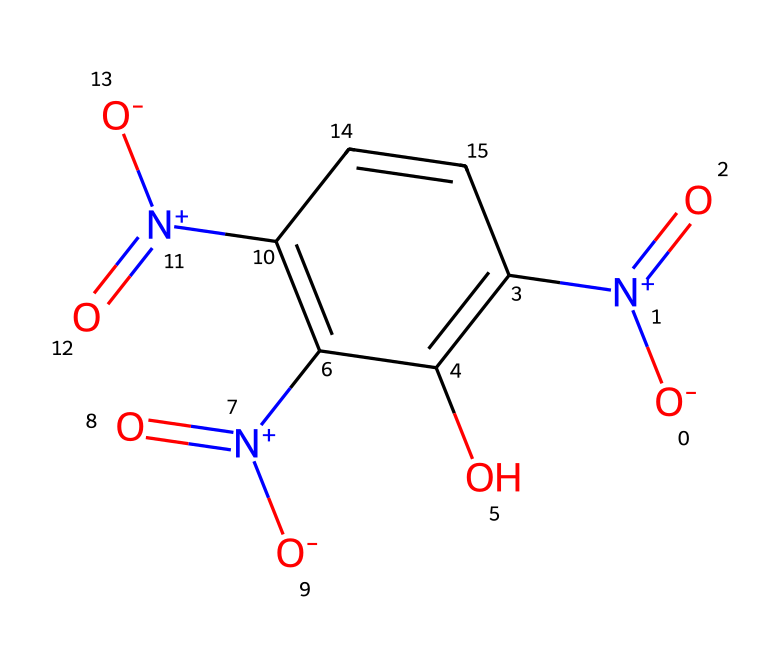What is the molecular formula of picric acid? By analyzing the structure, we identify the types and number of atoms present. Picric acid consists of carbon (C), hydrogen (H), nitrogen (N), and oxygen (O) atoms. Counting each, we have 6 carbon atoms, 3 hydrogen atoms, 3 nitrogen atoms, and 6 oxygen atoms, leading to the molecular formula C6H3N3O6.
Answer: C6H3N3O6 How many nitro groups are present in the structure? Looking at the structure, we see that there are three distinct -NO2 groups attached to the aromatic ring. Each nitro group can be identified by the presence of nitrogen bonded to two oxygen atoms. Counting these, we get three nitro groups in total.
Answer: 3 What type of compound is picric acid classified as? Picric acid has multiple nitro functional groups attached to an aromatic ring, which characterizes it as an aromatic explosive compound. The presence of these nitro groups classifies it as a nitro compound.
Answer: nitro compound Which functional group is responsible for the acidic property in picric acid? Upon examining the structure, we find a hydroxyl (-OH) group attached to the aromatic ring. This hydroxyl group is what gives picric acid its acidic properties, as it can donate a proton (H+) in solution.
Answer: hydroxyl group What is the total number of oxygen atoms in the structure? By directly counting the oxygen symbols from the chemical representation, we see there are six oxygen atoms present in picric acid. This includes the oxygen atoms from both the -OH group and the three nitro groups.
Answer: 6 